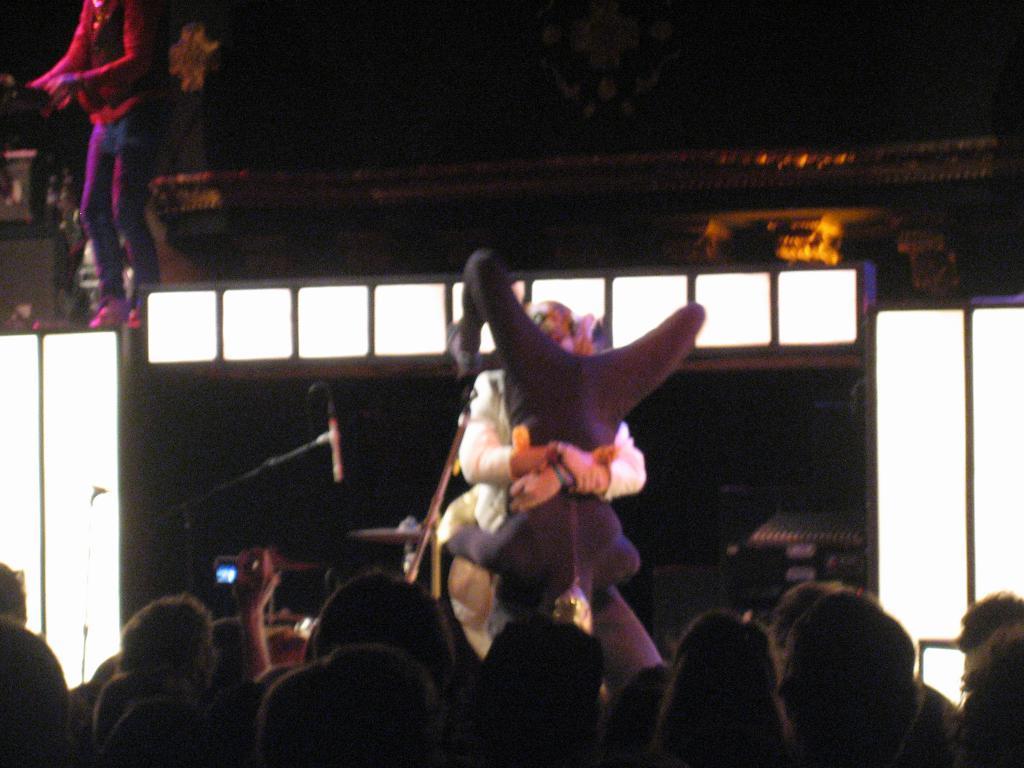Could you give a brief overview of what you see in this image? It is an edited image, there is a person holding another person upside down and in front of them there is a huge crowd. Behind that picture, on the top left there is an image of another person. 